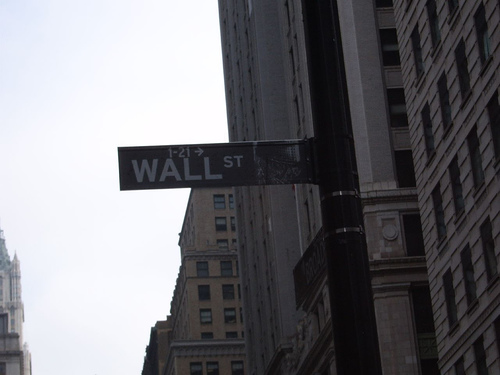Read and extract the text from this image. ST WALL 1 21 